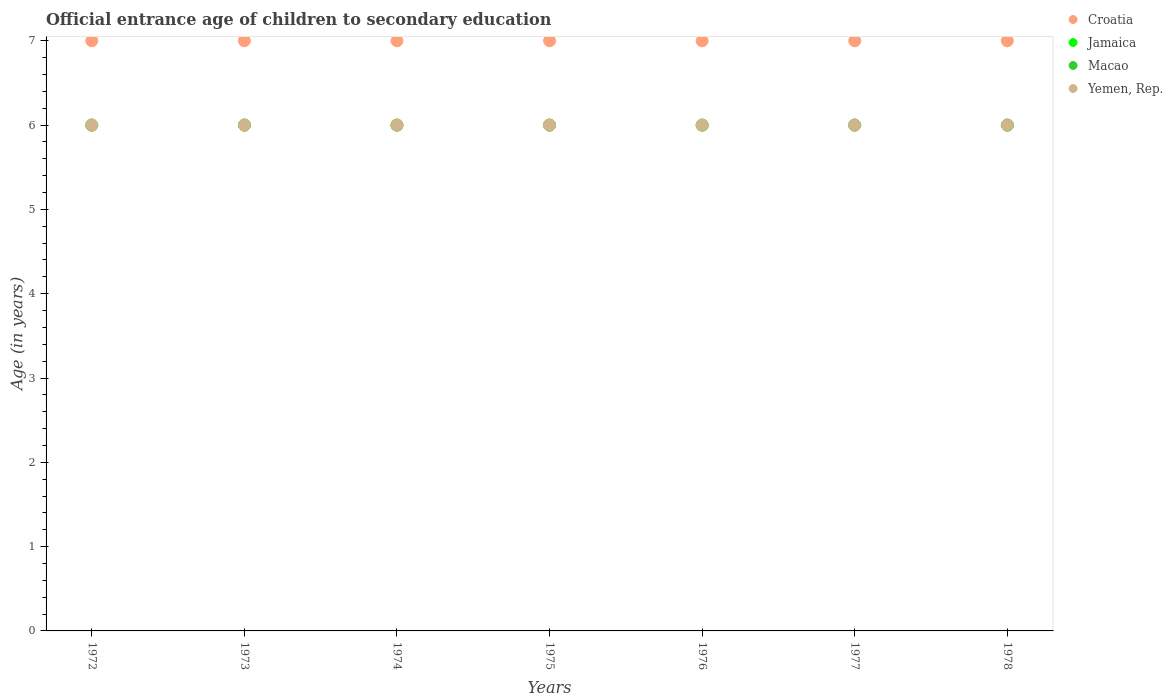What is the secondary school starting age of children in Croatia in 1976?
Make the answer very short. 7. What is the total secondary school starting age of children in Macao in the graph?
Offer a very short reply. 42. What is the difference between the secondary school starting age of children in Croatia in 1972 and that in 1978?
Ensure brevity in your answer.  0. In how many years, is the secondary school starting age of children in Jamaica greater than 6.4 years?
Provide a succinct answer. 0. Is the secondary school starting age of children in Macao in 1973 less than that in 1976?
Ensure brevity in your answer.  No. What is the difference between the highest and the second highest secondary school starting age of children in Jamaica?
Make the answer very short. 0. In how many years, is the secondary school starting age of children in Yemen, Rep. greater than the average secondary school starting age of children in Yemen, Rep. taken over all years?
Provide a short and direct response. 0. Is it the case that in every year, the sum of the secondary school starting age of children in Yemen, Rep. and secondary school starting age of children in Macao  is greater than the secondary school starting age of children in Jamaica?
Provide a succinct answer. Yes. Does the secondary school starting age of children in Macao monotonically increase over the years?
Your response must be concise. No. How many dotlines are there?
Make the answer very short. 4. What is the difference between two consecutive major ticks on the Y-axis?
Provide a succinct answer. 1. Where does the legend appear in the graph?
Offer a very short reply. Top right. How many legend labels are there?
Make the answer very short. 4. What is the title of the graph?
Make the answer very short. Official entrance age of children to secondary education. Does "Tunisia" appear as one of the legend labels in the graph?
Provide a succinct answer. No. What is the label or title of the Y-axis?
Make the answer very short. Age (in years). What is the Age (in years) of Jamaica in 1972?
Your response must be concise. 6. What is the Age (in years) in Macao in 1972?
Provide a short and direct response. 6. What is the Age (in years) in Yemen, Rep. in 1972?
Keep it short and to the point. 6. What is the Age (in years) in Croatia in 1973?
Offer a very short reply. 7. What is the Age (in years) of Macao in 1973?
Provide a succinct answer. 6. What is the Age (in years) of Jamaica in 1974?
Give a very brief answer. 6. What is the Age (in years) in Croatia in 1975?
Provide a succinct answer. 7. What is the Age (in years) in Jamaica in 1975?
Make the answer very short. 6. What is the Age (in years) of Macao in 1975?
Give a very brief answer. 6. What is the Age (in years) in Croatia in 1977?
Provide a succinct answer. 7. What is the Age (in years) in Yemen, Rep. in 1977?
Your answer should be compact. 6. What is the Age (in years) in Macao in 1978?
Offer a terse response. 6. What is the Age (in years) in Yemen, Rep. in 1978?
Ensure brevity in your answer.  6. Across all years, what is the maximum Age (in years) in Croatia?
Provide a short and direct response. 7. Across all years, what is the maximum Age (in years) of Jamaica?
Ensure brevity in your answer.  6. Across all years, what is the maximum Age (in years) in Macao?
Give a very brief answer. 6. Across all years, what is the minimum Age (in years) of Jamaica?
Provide a short and direct response. 6. What is the total Age (in years) in Jamaica in the graph?
Keep it short and to the point. 42. What is the total Age (in years) in Macao in the graph?
Your answer should be very brief. 42. What is the total Age (in years) in Yemen, Rep. in the graph?
Ensure brevity in your answer.  42. What is the difference between the Age (in years) in Croatia in 1972 and that in 1973?
Keep it short and to the point. 0. What is the difference between the Age (in years) in Croatia in 1972 and that in 1974?
Your answer should be compact. 0. What is the difference between the Age (in years) of Macao in 1972 and that in 1974?
Provide a short and direct response. 0. What is the difference between the Age (in years) in Yemen, Rep. in 1972 and that in 1974?
Keep it short and to the point. 0. What is the difference between the Age (in years) in Jamaica in 1972 and that in 1975?
Provide a short and direct response. 0. What is the difference between the Age (in years) of Macao in 1972 and that in 1975?
Offer a very short reply. 0. What is the difference between the Age (in years) in Yemen, Rep. in 1972 and that in 1975?
Offer a terse response. 0. What is the difference between the Age (in years) of Croatia in 1972 and that in 1976?
Your response must be concise. 0. What is the difference between the Age (in years) in Jamaica in 1972 and that in 1976?
Make the answer very short. 0. What is the difference between the Age (in years) of Yemen, Rep. in 1972 and that in 1977?
Ensure brevity in your answer.  0. What is the difference between the Age (in years) of Croatia in 1972 and that in 1978?
Provide a succinct answer. 0. What is the difference between the Age (in years) of Macao in 1972 and that in 1978?
Offer a terse response. 0. What is the difference between the Age (in years) in Yemen, Rep. in 1972 and that in 1978?
Your response must be concise. 0. What is the difference between the Age (in years) in Croatia in 1973 and that in 1974?
Provide a succinct answer. 0. What is the difference between the Age (in years) of Jamaica in 1973 and that in 1974?
Give a very brief answer. 0. What is the difference between the Age (in years) of Macao in 1973 and that in 1974?
Your answer should be very brief. 0. What is the difference between the Age (in years) of Yemen, Rep. in 1973 and that in 1974?
Ensure brevity in your answer.  0. What is the difference between the Age (in years) of Jamaica in 1973 and that in 1975?
Your answer should be very brief. 0. What is the difference between the Age (in years) of Yemen, Rep. in 1973 and that in 1975?
Provide a short and direct response. 0. What is the difference between the Age (in years) of Yemen, Rep. in 1973 and that in 1977?
Provide a short and direct response. 0. What is the difference between the Age (in years) of Croatia in 1973 and that in 1978?
Offer a terse response. 0. What is the difference between the Age (in years) in Jamaica in 1973 and that in 1978?
Offer a very short reply. 0. What is the difference between the Age (in years) of Macao in 1973 and that in 1978?
Give a very brief answer. 0. What is the difference between the Age (in years) in Croatia in 1974 and that in 1975?
Ensure brevity in your answer.  0. What is the difference between the Age (in years) in Yemen, Rep. in 1974 and that in 1976?
Your answer should be very brief. 0. What is the difference between the Age (in years) of Jamaica in 1974 and that in 1977?
Your answer should be compact. 0. What is the difference between the Age (in years) of Macao in 1974 and that in 1977?
Your answer should be very brief. 0. What is the difference between the Age (in years) of Macao in 1974 and that in 1978?
Your response must be concise. 0. What is the difference between the Age (in years) in Yemen, Rep. in 1974 and that in 1978?
Provide a short and direct response. 0. What is the difference between the Age (in years) of Croatia in 1975 and that in 1976?
Give a very brief answer. 0. What is the difference between the Age (in years) in Croatia in 1975 and that in 1977?
Your answer should be very brief. 0. What is the difference between the Age (in years) of Jamaica in 1975 and that in 1977?
Make the answer very short. 0. What is the difference between the Age (in years) of Jamaica in 1975 and that in 1978?
Provide a succinct answer. 0. What is the difference between the Age (in years) in Croatia in 1976 and that in 1977?
Offer a very short reply. 0. What is the difference between the Age (in years) in Jamaica in 1976 and that in 1977?
Provide a short and direct response. 0. What is the difference between the Age (in years) in Jamaica in 1976 and that in 1978?
Ensure brevity in your answer.  0. What is the difference between the Age (in years) in Yemen, Rep. in 1976 and that in 1978?
Your answer should be compact. 0. What is the difference between the Age (in years) in Croatia in 1977 and that in 1978?
Provide a succinct answer. 0. What is the difference between the Age (in years) of Jamaica in 1977 and that in 1978?
Provide a short and direct response. 0. What is the difference between the Age (in years) in Croatia in 1972 and the Age (in years) in Jamaica in 1973?
Your answer should be compact. 1. What is the difference between the Age (in years) of Croatia in 1972 and the Age (in years) of Macao in 1973?
Make the answer very short. 1. What is the difference between the Age (in years) of Jamaica in 1972 and the Age (in years) of Yemen, Rep. in 1973?
Keep it short and to the point. 0. What is the difference between the Age (in years) in Croatia in 1972 and the Age (in years) in Macao in 1974?
Your response must be concise. 1. What is the difference between the Age (in years) of Jamaica in 1972 and the Age (in years) of Macao in 1974?
Provide a short and direct response. 0. What is the difference between the Age (in years) in Jamaica in 1972 and the Age (in years) in Yemen, Rep. in 1974?
Offer a terse response. 0. What is the difference between the Age (in years) of Croatia in 1972 and the Age (in years) of Jamaica in 1975?
Provide a short and direct response. 1. What is the difference between the Age (in years) in Croatia in 1972 and the Age (in years) in Yemen, Rep. in 1975?
Give a very brief answer. 1. What is the difference between the Age (in years) of Macao in 1972 and the Age (in years) of Yemen, Rep. in 1975?
Make the answer very short. 0. What is the difference between the Age (in years) in Croatia in 1972 and the Age (in years) in Yemen, Rep. in 1976?
Your response must be concise. 1. What is the difference between the Age (in years) in Jamaica in 1972 and the Age (in years) in Macao in 1976?
Your response must be concise. 0. What is the difference between the Age (in years) of Macao in 1972 and the Age (in years) of Yemen, Rep. in 1976?
Your answer should be compact. 0. What is the difference between the Age (in years) in Jamaica in 1972 and the Age (in years) in Macao in 1977?
Ensure brevity in your answer.  0. What is the difference between the Age (in years) of Macao in 1972 and the Age (in years) of Yemen, Rep. in 1977?
Your answer should be very brief. 0. What is the difference between the Age (in years) of Croatia in 1972 and the Age (in years) of Jamaica in 1978?
Provide a short and direct response. 1. What is the difference between the Age (in years) in Croatia in 1972 and the Age (in years) in Macao in 1978?
Offer a very short reply. 1. What is the difference between the Age (in years) of Jamaica in 1972 and the Age (in years) of Macao in 1978?
Your answer should be compact. 0. What is the difference between the Age (in years) of Jamaica in 1972 and the Age (in years) of Yemen, Rep. in 1978?
Make the answer very short. 0. What is the difference between the Age (in years) of Macao in 1972 and the Age (in years) of Yemen, Rep. in 1978?
Keep it short and to the point. 0. What is the difference between the Age (in years) of Croatia in 1973 and the Age (in years) of Jamaica in 1974?
Offer a very short reply. 1. What is the difference between the Age (in years) of Croatia in 1973 and the Age (in years) of Macao in 1974?
Provide a short and direct response. 1. What is the difference between the Age (in years) in Croatia in 1973 and the Age (in years) in Yemen, Rep. in 1974?
Provide a short and direct response. 1. What is the difference between the Age (in years) in Macao in 1973 and the Age (in years) in Yemen, Rep. in 1974?
Give a very brief answer. 0. What is the difference between the Age (in years) in Croatia in 1973 and the Age (in years) in Jamaica in 1975?
Ensure brevity in your answer.  1. What is the difference between the Age (in years) in Croatia in 1973 and the Age (in years) in Macao in 1975?
Make the answer very short. 1. What is the difference between the Age (in years) of Jamaica in 1973 and the Age (in years) of Yemen, Rep. in 1975?
Make the answer very short. 0. What is the difference between the Age (in years) of Macao in 1973 and the Age (in years) of Yemen, Rep. in 1975?
Offer a very short reply. 0. What is the difference between the Age (in years) in Croatia in 1973 and the Age (in years) in Jamaica in 1976?
Offer a terse response. 1. What is the difference between the Age (in years) in Croatia in 1973 and the Age (in years) in Yemen, Rep. in 1976?
Make the answer very short. 1. What is the difference between the Age (in years) in Jamaica in 1973 and the Age (in years) in Macao in 1976?
Offer a very short reply. 0. What is the difference between the Age (in years) of Jamaica in 1973 and the Age (in years) of Yemen, Rep. in 1976?
Give a very brief answer. 0. What is the difference between the Age (in years) of Jamaica in 1973 and the Age (in years) of Macao in 1977?
Your response must be concise. 0. What is the difference between the Age (in years) in Croatia in 1973 and the Age (in years) in Macao in 1978?
Provide a short and direct response. 1. What is the difference between the Age (in years) of Jamaica in 1973 and the Age (in years) of Macao in 1978?
Provide a short and direct response. 0. What is the difference between the Age (in years) in Jamaica in 1973 and the Age (in years) in Yemen, Rep. in 1978?
Keep it short and to the point. 0. What is the difference between the Age (in years) in Macao in 1973 and the Age (in years) in Yemen, Rep. in 1978?
Keep it short and to the point. 0. What is the difference between the Age (in years) in Croatia in 1974 and the Age (in years) in Jamaica in 1975?
Your answer should be compact. 1. What is the difference between the Age (in years) in Croatia in 1974 and the Age (in years) in Macao in 1975?
Ensure brevity in your answer.  1. What is the difference between the Age (in years) of Macao in 1974 and the Age (in years) of Yemen, Rep. in 1975?
Your answer should be compact. 0. What is the difference between the Age (in years) of Croatia in 1974 and the Age (in years) of Macao in 1976?
Ensure brevity in your answer.  1. What is the difference between the Age (in years) in Croatia in 1974 and the Age (in years) in Yemen, Rep. in 1976?
Offer a very short reply. 1. What is the difference between the Age (in years) in Jamaica in 1974 and the Age (in years) in Yemen, Rep. in 1976?
Offer a terse response. 0. What is the difference between the Age (in years) in Croatia in 1974 and the Age (in years) in Jamaica in 1978?
Give a very brief answer. 1. What is the difference between the Age (in years) in Croatia in 1974 and the Age (in years) in Macao in 1978?
Your answer should be compact. 1. What is the difference between the Age (in years) in Jamaica in 1974 and the Age (in years) in Yemen, Rep. in 1978?
Your response must be concise. 0. What is the difference between the Age (in years) of Macao in 1974 and the Age (in years) of Yemen, Rep. in 1978?
Make the answer very short. 0. What is the difference between the Age (in years) in Croatia in 1975 and the Age (in years) in Jamaica in 1976?
Your response must be concise. 1. What is the difference between the Age (in years) of Croatia in 1975 and the Age (in years) of Macao in 1976?
Provide a succinct answer. 1. What is the difference between the Age (in years) in Jamaica in 1975 and the Age (in years) in Yemen, Rep. in 1976?
Keep it short and to the point. 0. What is the difference between the Age (in years) of Macao in 1975 and the Age (in years) of Yemen, Rep. in 1976?
Provide a short and direct response. 0. What is the difference between the Age (in years) of Croatia in 1975 and the Age (in years) of Yemen, Rep. in 1978?
Keep it short and to the point. 1. What is the difference between the Age (in years) in Macao in 1975 and the Age (in years) in Yemen, Rep. in 1978?
Offer a terse response. 0. What is the difference between the Age (in years) of Croatia in 1976 and the Age (in years) of Jamaica in 1977?
Make the answer very short. 1. What is the difference between the Age (in years) in Croatia in 1976 and the Age (in years) in Macao in 1977?
Your answer should be very brief. 1. What is the difference between the Age (in years) in Croatia in 1976 and the Age (in years) in Yemen, Rep. in 1977?
Your response must be concise. 1. What is the difference between the Age (in years) of Jamaica in 1976 and the Age (in years) of Yemen, Rep. in 1977?
Make the answer very short. 0. What is the difference between the Age (in years) in Croatia in 1976 and the Age (in years) in Jamaica in 1978?
Ensure brevity in your answer.  1. What is the difference between the Age (in years) of Croatia in 1976 and the Age (in years) of Macao in 1978?
Provide a short and direct response. 1. What is the difference between the Age (in years) in Jamaica in 1976 and the Age (in years) in Macao in 1978?
Your answer should be compact. 0. What is the difference between the Age (in years) in Macao in 1976 and the Age (in years) in Yemen, Rep. in 1978?
Provide a succinct answer. 0. What is the difference between the Age (in years) of Croatia in 1977 and the Age (in years) of Jamaica in 1978?
Ensure brevity in your answer.  1. What is the difference between the Age (in years) in Croatia in 1977 and the Age (in years) in Yemen, Rep. in 1978?
Your answer should be very brief. 1. What is the difference between the Age (in years) of Jamaica in 1977 and the Age (in years) of Macao in 1978?
Make the answer very short. 0. What is the average Age (in years) in Croatia per year?
Ensure brevity in your answer.  7. What is the average Age (in years) in Jamaica per year?
Your answer should be very brief. 6. What is the average Age (in years) in Macao per year?
Offer a very short reply. 6. What is the average Age (in years) in Yemen, Rep. per year?
Provide a short and direct response. 6. In the year 1972, what is the difference between the Age (in years) of Croatia and Age (in years) of Macao?
Provide a succinct answer. 1. In the year 1972, what is the difference between the Age (in years) in Jamaica and Age (in years) in Yemen, Rep.?
Ensure brevity in your answer.  0. In the year 1973, what is the difference between the Age (in years) of Croatia and Age (in years) of Macao?
Your answer should be very brief. 1. In the year 1973, what is the difference between the Age (in years) in Croatia and Age (in years) in Yemen, Rep.?
Your answer should be very brief. 1. In the year 1974, what is the difference between the Age (in years) in Jamaica and Age (in years) in Macao?
Your answer should be compact. 0. In the year 1974, what is the difference between the Age (in years) of Jamaica and Age (in years) of Yemen, Rep.?
Provide a succinct answer. 0. In the year 1975, what is the difference between the Age (in years) of Croatia and Age (in years) of Jamaica?
Provide a short and direct response. 1. In the year 1975, what is the difference between the Age (in years) of Croatia and Age (in years) of Macao?
Offer a terse response. 1. In the year 1976, what is the difference between the Age (in years) of Croatia and Age (in years) of Yemen, Rep.?
Your answer should be compact. 1. In the year 1976, what is the difference between the Age (in years) in Macao and Age (in years) in Yemen, Rep.?
Your answer should be very brief. 0. In the year 1977, what is the difference between the Age (in years) in Croatia and Age (in years) in Macao?
Your response must be concise. 1. In the year 1977, what is the difference between the Age (in years) in Croatia and Age (in years) in Yemen, Rep.?
Your answer should be compact. 1. In the year 1978, what is the difference between the Age (in years) in Croatia and Age (in years) in Jamaica?
Your answer should be compact. 1. In the year 1978, what is the difference between the Age (in years) in Croatia and Age (in years) in Yemen, Rep.?
Your response must be concise. 1. In the year 1978, what is the difference between the Age (in years) of Jamaica and Age (in years) of Macao?
Ensure brevity in your answer.  0. In the year 1978, what is the difference between the Age (in years) in Jamaica and Age (in years) in Yemen, Rep.?
Give a very brief answer. 0. In the year 1978, what is the difference between the Age (in years) of Macao and Age (in years) of Yemen, Rep.?
Provide a short and direct response. 0. What is the ratio of the Age (in years) of Macao in 1972 to that in 1973?
Provide a succinct answer. 1. What is the ratio of the Age (in years) of Yemen, Rep. in 1972 to that in 1973?
Make the answer very short. 1. What is the ratio of the Age (in years) in Croatia in 1972 to that in 1974?
Offer a very short reply. 1. What is the ratio of the Age (in years) in Croatia in 1972 to that in 1975?
Provide a short and direct response. 1. What is the ratio of the Age (in years) in Yemen, Rep. in 1972 to that in 1975?
Provide a short and direct response. 1. What is the ratio of the Age (in years) in Croatia in 1972 to that in 1976?
Your answer should be compact. 1. What is the ratio of the Age (in years) in Yemen, Rep. in 1972 to that in 1976?
Offer a terse response. 1. What is the ratio of the Age (in years) in Croatia in 1972 to that in 1977?
Your answer should be very brief. 1. What is the ratio of the Age (in years) in Macao in 1972 to that in 1977?
Your answer should be compact. 1. What is the ratio of the Age (in years) of Yemen, Rep. in 1972 to that in 1977?
Provide a succinct answer. 1. What is the ratio of the Age (in years) of Croatia in 1972 to that in 1978?
Ensure brevity in your answer.  1. What is the ratio of the Age (in years) of Jamaica in 1972 to that in 1978?
Your response must be concise. 1. What is the ratio of the Age (in years) in Jamaica in 1973 to that in 1974?
Keep it short and to the point. 1. What is the ratio of the Age (in years) of Macao in 1973 to that in 1974?
Your answer should be very brief. 1. What is the ratio of the Age (in years) of Yemen, Rep. in 1973 to that in 1974?
Provide a short and direct response. 1. What is the ratio of the Age (in years) of Croatia in 1973 to that in 1975?
Provide a short and direct response. 1. What is the ratio of the Age (in years) in Jamaica in 1973 to that in 1975?
Offer a very short reply. 1. What is the ratio of the Age (in years) in Macao in 1973 to that in 1975?
Ensure brevity in your answer.  1. What is the ratio of the Age (in years) in Yemen, Rep. in 1973 to that in 1975?
Your answer should be very brief. 1. What is the ratio of the Age (in years) in Jamaica in 1973 to that in 1977?
Give a very brief answer. 1. What is the ratio of the Age (in years) of Macao in 1973 to that in 1977?
Ensure brevity in your answer.  1. What is the ratio of the Age (in years) in Yemen, Rep. in 1973 to that in 1977?
Ensure brevity in your answer.  1. What is the ratio of the Age (in years) in Croatia in 1973 to that in 1978?
Offer a very short reply. 1. What is the ratio of the Age (in years) in Jamaica in 1973 to that in 1978?
Keep it short and to the point. 1. What is the ratio of the Age (in years) of Macao in 1973 to that in 1978?
Your response must be concise. 1. What is the ratio of the Age (in years) of Yemen, Rep. in 1973 to that in 1978?
Your answer should be very brief. 1. What is the ratio of the Age (in years) of Jamaica in 1974 to that in 1975?
Offer a very short reply. 1. What is the ratio of the Age (in years) in Yemen, Rep. in 1974 to that in 1975?
Your response must be concise. 1. What is the ratio of the Age (in years) of Yemen, Rep. in 1974 to that in 1976?
Keep it short and to the point. 1. What is the ratio of the Age (in years) in Macao in 1974 to that in 1977?
Provide a succinct answer. 1. What is the ratio of the Age (in years) of Yemen, Rep. in 1974 to that in 1977?
Your answer should be very brief. 1. What is the ratio of the Age (in years) of Croatia in 1974 to that in 1978?
Your answer should be very brief. 1. What is the ratio of the Age (in years) in Macao in 1974 to that in 1978?
Offer a terse response. 1. What is the ratio of the Age (in years) in Yemen, Rep. in 1974 to that in 1978?
Offer a terse response. 1. What is the ratio of the Age (in years) in Croatia in 1975 to that in 1976?
Offer a very short reply. 1. What is the ratio of the Age (in years) of Jamaica in 1975 to that in 1976?
Your response must be concise. 1. What is the ratio of the Age (in years) of Yemen, Rep. in 1975 to that in 1976?
Offer a very short reply. 1. What is the ratio of the Age (in years) of Yemen, Rep. in 1975 to that in 1977?
Ensure brevity in your answer.  1. What is the ratio of the Age (in years) of Croatia in 1975 to that in 1978?
Ensure brevity in your answer.  1. What is the ratio of the Age (in years) in Macao in 1975 to that in 1978?
Ensure brevity in your answer.  1. What is the ratio of the Age (in years) in Yemen, Rep. in 1975 to that in 1978?
Make the answer very short. 1. What is the ratio of the Age (in years) of Jamaica in 1976 to that in 1977?
Keep it short and to the point. 1. What is the ratio of the Age (in years) in Yemen, Rep. in 1976 to that in 1977?
Your answer should be compact. 1. What is the ratio of the Age (in years) of Croatia in 1976 to that in 1978?
Offer a terse response. 1. What is the ratio of the Age (in years) of Jamaica in 1976 to that in 1978?
Keep it short and to the point. 1. What is the ratio of the Age (in years) in Macao in 1976 to that in 1978?
Ensure brevity in your answer.  1. What is the ratio of the Age (in years) in Jamaica in 1977 to that in 1978?
Your answer should be compact. 1. What is the ratio of the Age (in years) of Yemen, Rep. in 1977 to that in 1978?
Offer a terse response. 1. What is the difference between the highest and the lowest Age (in years) of Croatia?
Your answer should be compact. 0. What is the difference between the highest and the lowest Age (in years) of Jamaica?
Your response must be concise. 0. What is the difference between the highest and the lowest Age (in years) in Yemen, Rep.?
Give a very brief answer. 0. 